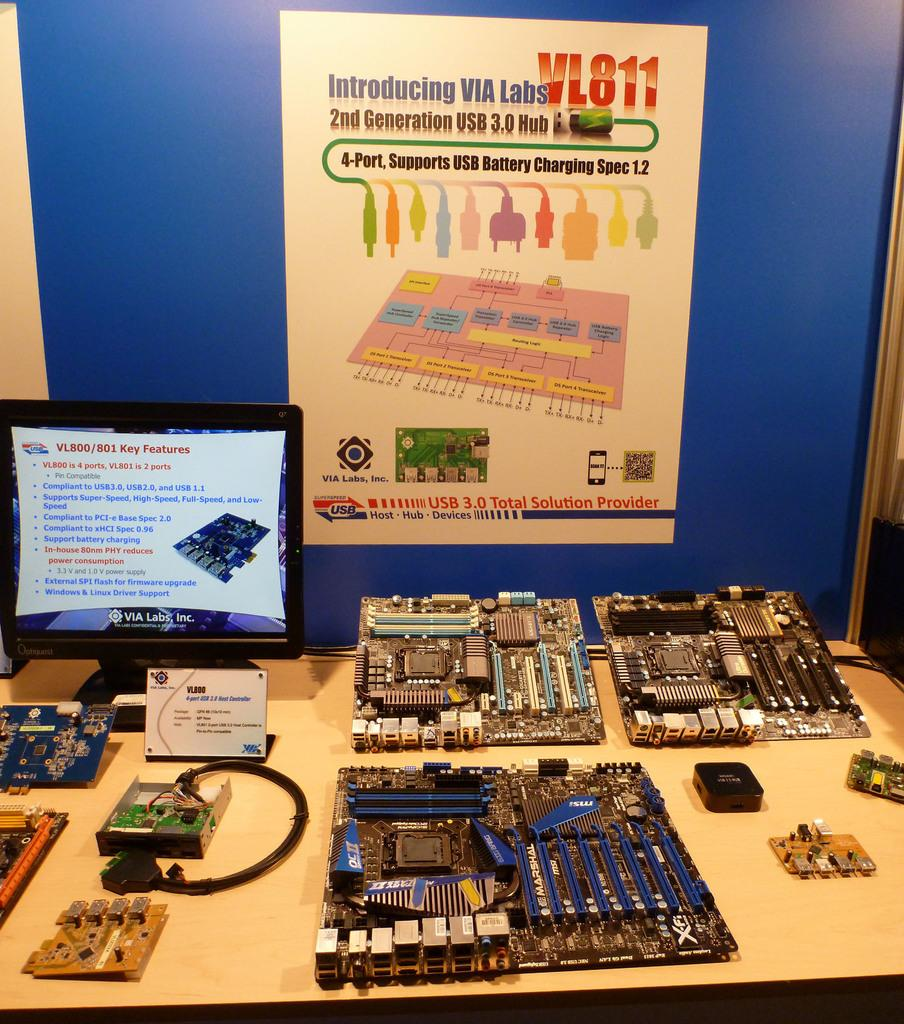<image>
Create a compact narrative representing the image presented. COmputer parts on a table under a sign that says "Introducing VIA LABS VL811". 